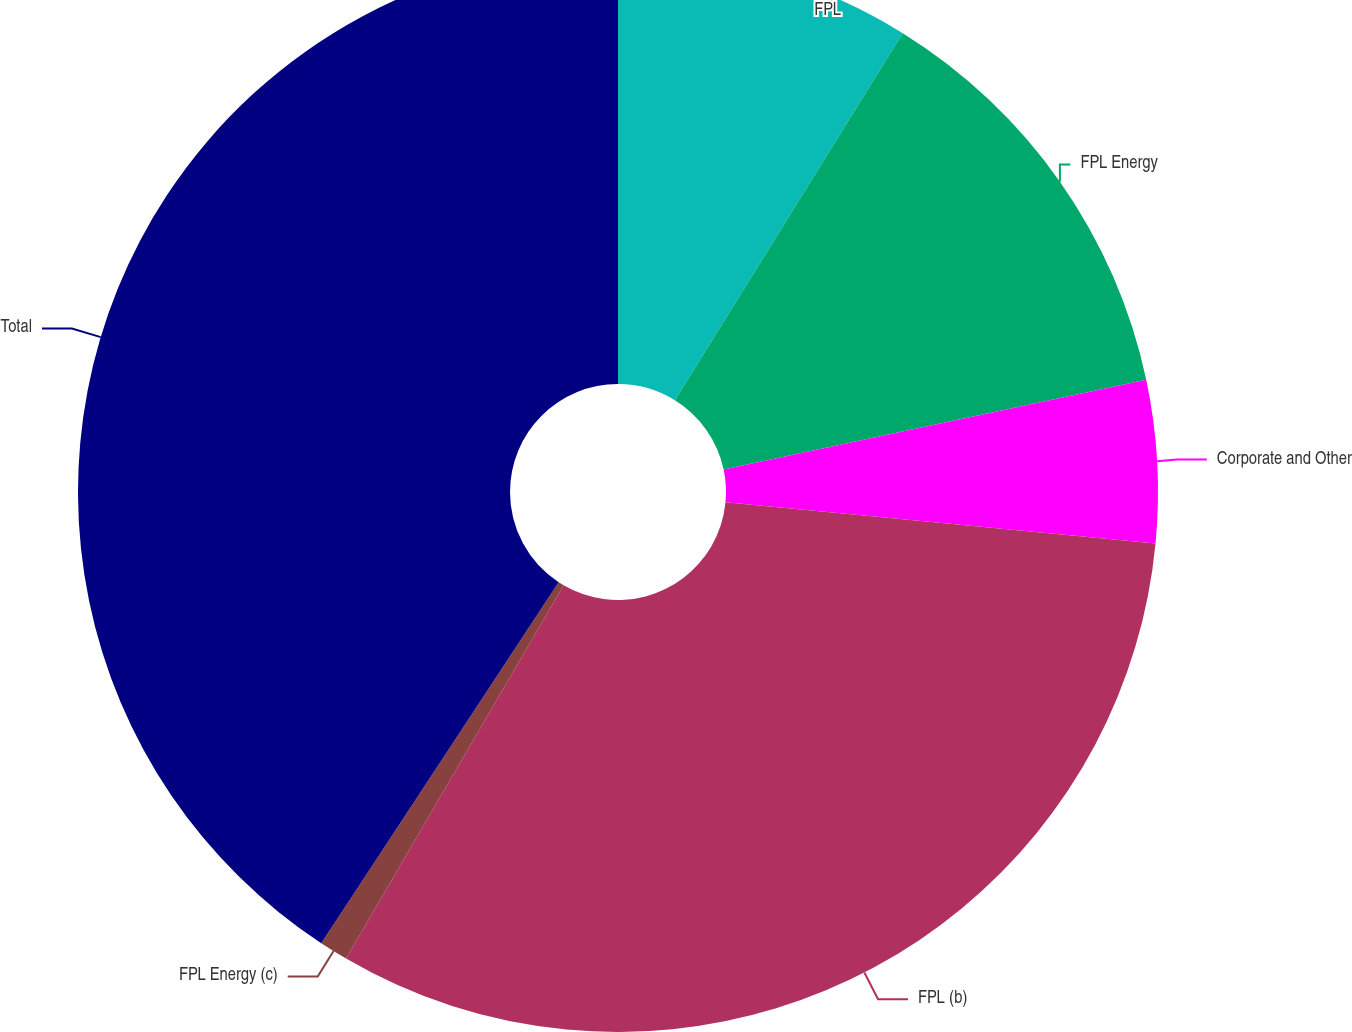Convert chart to OTSL. <chart><loc_0><loc_0><loc_500><loc_500><pie_chart><fcel>FPL<fcel>FPL Energy<fcel>Corporate and Other<fcel>FPL (b)<fcel>FPL Energy (c)<fcel>Total<nl><fcel>8.84%<fcel>12.83%<fcel>4.85%<fcel>31.88%<fcel>0.86%<fcel>40.74%<nl></chart> 